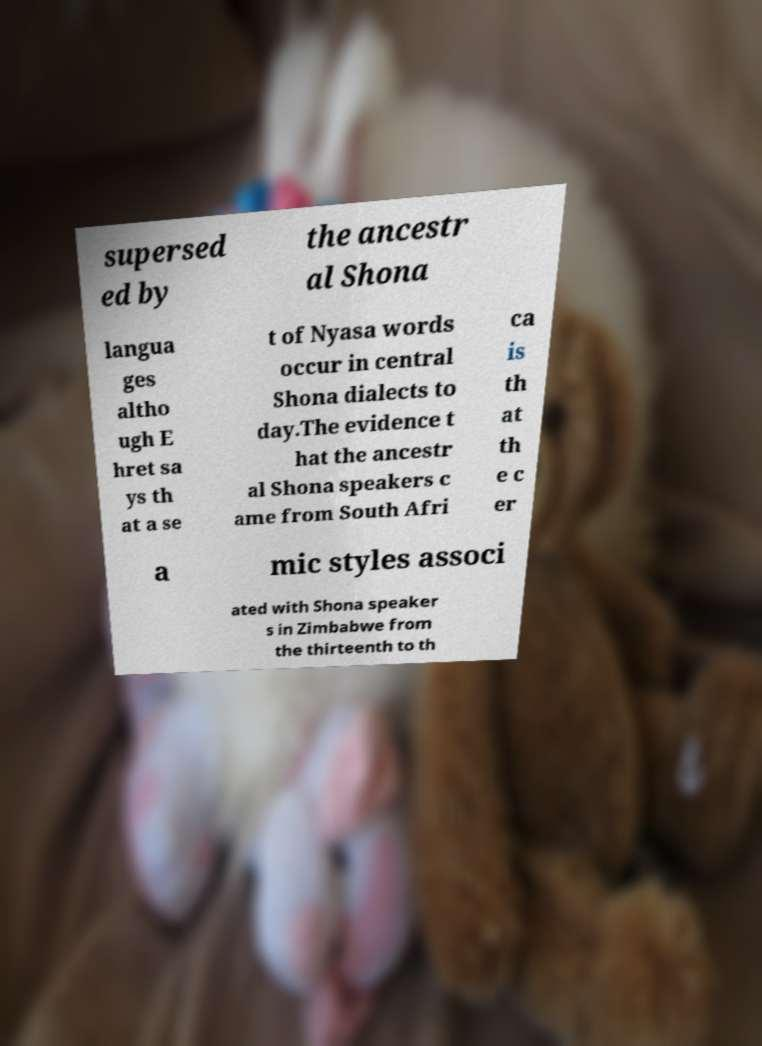What messages or text are displayed in this image? I need them in a readable, typed format. supersed ed by the ancestr al Shona langua ges altho ugh E hret sa ys th at a se t of Nyasa words occur in central Shona dialects to day.The evidence t hat the ancestr al Shona speakers c ame from South Afri ca is th at th e c er a mic styles associ ated with Shona speaker s in Zimbabwe from the thirteenth to th 